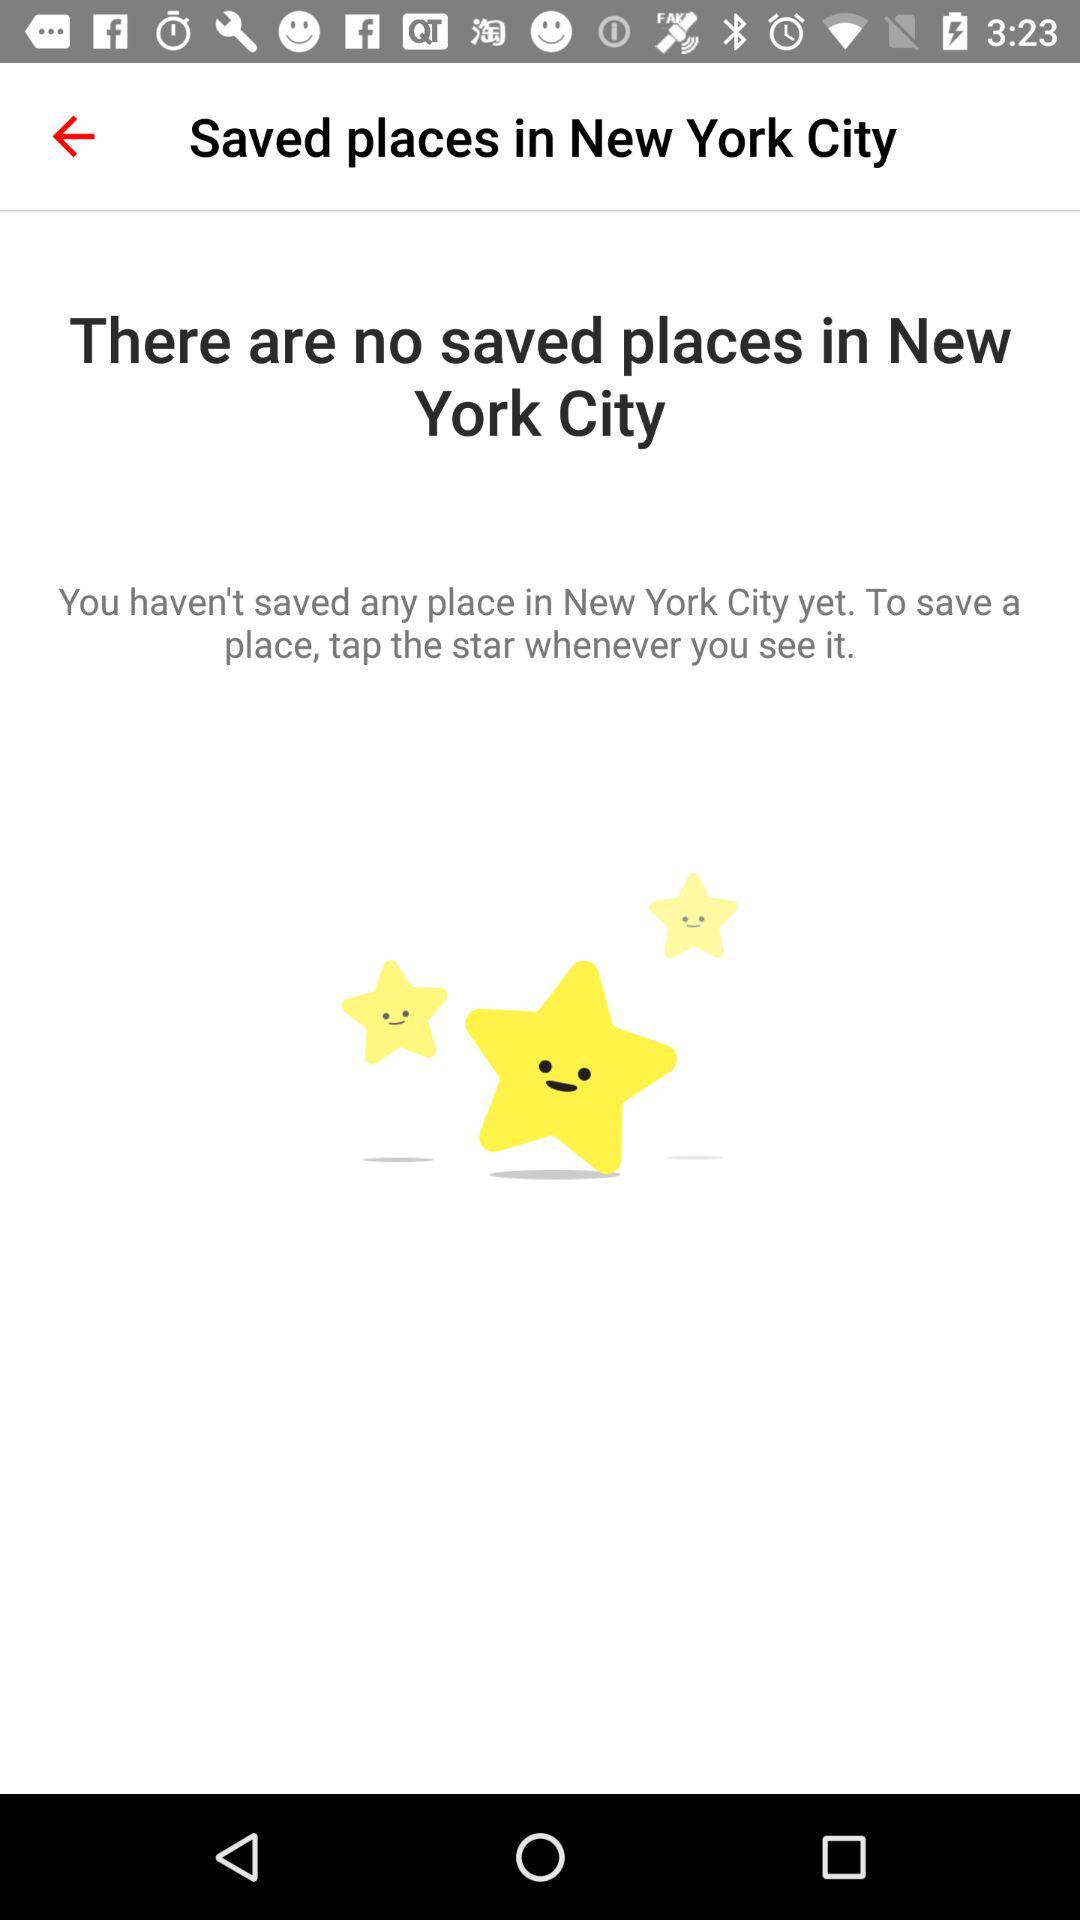How many places in New York City can we save?
When the provided information is insufficient, respond with <no answer>. <no answer> 